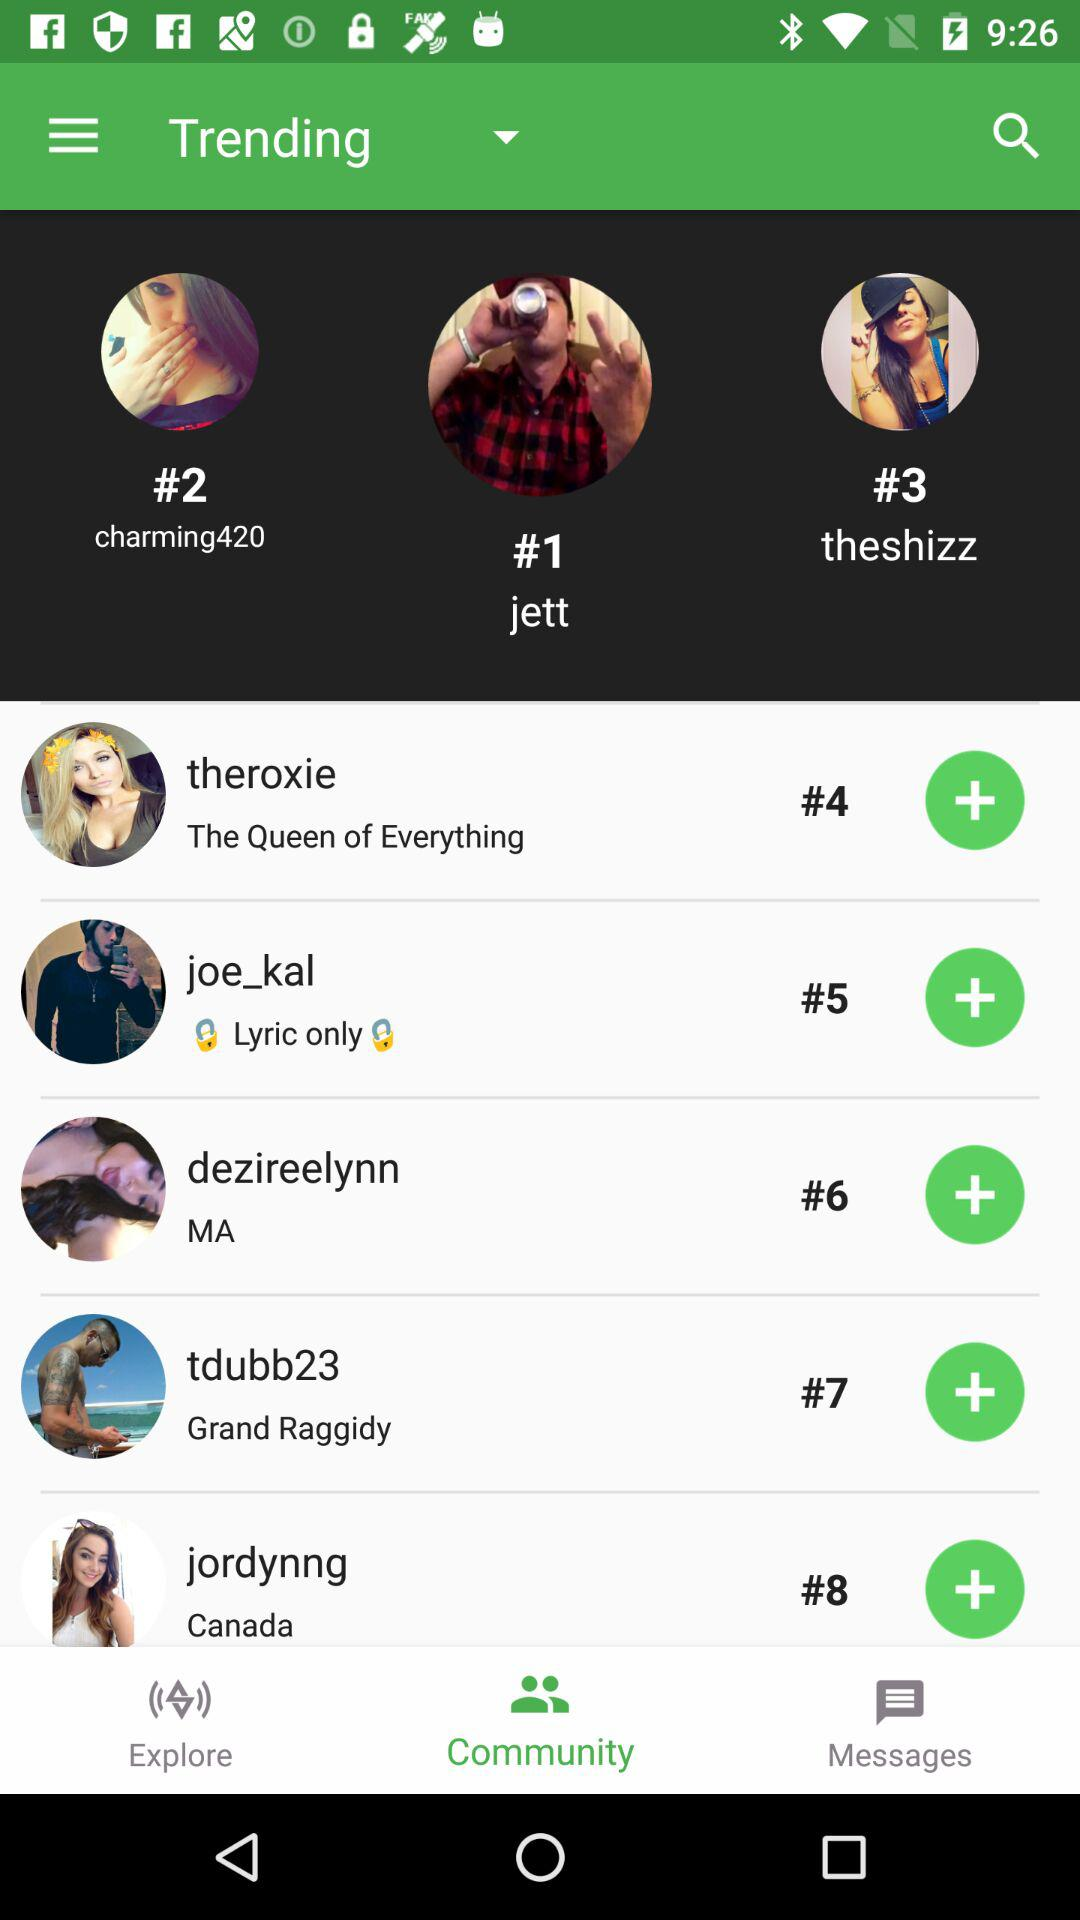Who is on #1? It is "jett" who is on #1. 